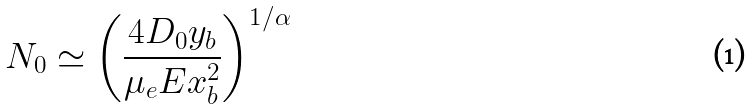Convert formula to latex. <formula><loc_0><loc_0><loc_500><loc_500>N _ { 0 } \simeq \left ( \frac { 4 D _ { 0 } y _ { b } } { \mu _ { e } E x _ { b } ^ { 2 } } \right ) ^ { 1 / \alpha }</formula> 